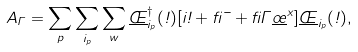Convert formula to latex. <formula><loc_0><loc_0><loc_500><loc_500>A _ { \Gamma } = \sum _ { p } \sum _ { i _ { p } } \sum _ { w } \underline { \phi } ^ { \dagger } _ { i _ { p } } ( \omega ) [ i \omega + \beta \mu + \beta \Gamma \underline { \sigma } ^ { x } ] \underline { \phi } _ { i _ { p } } ( \omega ) ,</formula> 